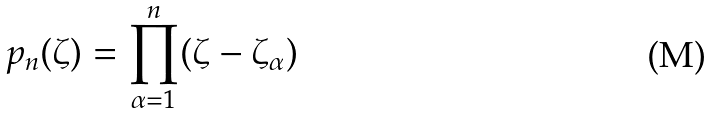Convert formula to latex. <formula><loc_0><loc_0><loc_500><loc_500>p _ { n } ( \zeta ) = \prod _ { \alpha = 1 } ^ { n } ( \zeta - \zeta _ { \alpha } )</formula> 